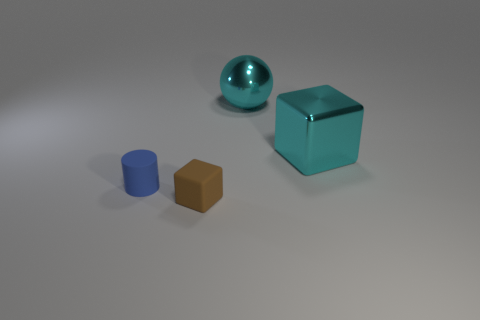Is the number of cyan cubes that are to the left of the big shiny sphere the same as the number of cyan things?
Your answer should be compact. No. What number of small cylinders are made of the same material as the brown thing?
Provide a succinct answer. 1. There is a big ball that is the same material as the big cyan cube; what color is it?
Provide a short and direct response. Cyan. There is a matte cylinder; does it have the same size as the matte object that is in front of the blue matte thing?
Provide a short and direct response. Yes. The blue rubber thing is what shape?
Provide a succinct answer. Cylinder. What number of other metal balls are the same color as the large shiny ball?
Your answer should be compact. 0. There is another big object that is the same shape as the brown thing; what is its color?
Keep it short and to the point. Cyan. How many small rubber blocks are to the left of the matte cylinder that is to the left of the tiny brown thing?
Keep it short and to the point. 0. What number of spheres are either brown objects or large cyan metallic things?
Keep it short and to the point. 1. Are there any big green things?
Make the answer very short. No. 